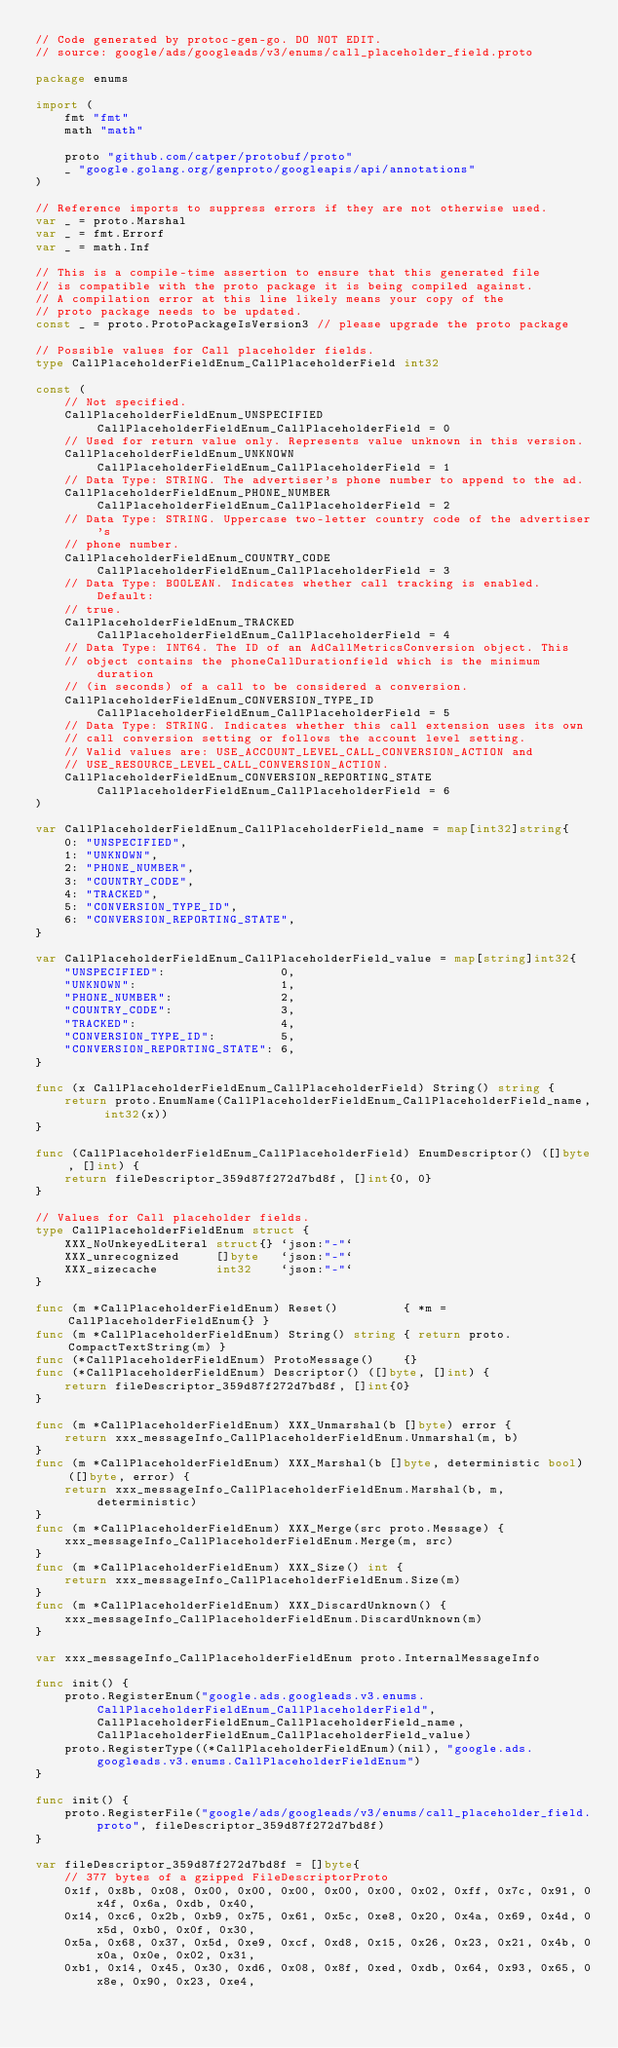<code> <loc_0><loc_0><loc_500><loc_500><_Go_>// Code generated by protoc-gen-go. DO NOT EDIT.
// source: google/ads/googleads/v3/enums/call_placeholder_field.proto

package enums

import (
	fmt "fmt"
	math "math"

	proto "github.com/catper/protobuf/proto"
	_ "google.golang.org/genproto/googleapis/api/annotations"
)

// Reference imports to suppress errors if they are not otherwise used.
var _ = proto.Marshal
var _ = fmt.Errorf
var _ = math.Inf

// This is a compile-time assertion to ensure that this generated file
// is compatible with the proto package it is being compiled against.
// A compilation error at this line likely means your copy of the
// proto package needs to be updated.
const _ = proto.ProtoPackageIsVersion3 // please upgrade the proto package

// Possible values for Call placeholder fields.
type CallPlaceholderFieldEnum_CallPlaceholderField int32

const (
	// Not specified.
	CallPlaceholderFieldEnum_UNSPECIFIED CallPlaceholderFieldEnum_CallPlaceholderField = 0
	// Used for return value only. Represents value unknown in this version.
	CallPlaceholderFieldEnum_UNKNOWN CallPlaceholderFieldEnum_CallPlaceholderField = 1
	// Data Type: STRING. The advertiser's phone number to append to the ad.
	CallPlaceholderFieldEnum_PHONE_NUMBER CallPlaceholderFieldEnum_CallPlaceholderField = 2
	// Data Type: STRING. Uppercase two-letter country code of the advertiser's
	// phone number.
	CallPlaceholderFieldEnum_COUNTRY_CODE CallPlaceholderFieldEnum_CallPlaceholderField = 3
	// Data Type: BOOLEAN. Indicates whether call tracking is enabled. Default:
	// true.
	CallPlaceholderFieldEnum_TRACKED CallPlaceholderFieldEnum_CallPlaceholderField = 4
	// Data Type: INT64. The ID of an AdCallMetricsConversion object. This
	// object contains the phoneCallDurationfield which is the minimum duration
	// (in seconds) of a call to be considered a conversion.
	CallPlaceholderFieldEnum_CONVERSION_TYPE_ID CallPlaceholderFieldEnum_CallPlaceholderField = 5
	// Data Type: STRING. Indicates whether this call extension uses its own
	// call conversion setting or follows the account level setting.
	// Valid values are: USE_ACCOUNT_LEVEL_CALL_CONVERSION_ACTION and
	// USE_RESOURCE_LEVEL_CALL_CONVERSION_ACTION.
	CallPlaceholderFieldEnum_CONVERSION_REPORTING_STATE CallPlaceholderFieldEnum_CallPlaceholderField = 6
)

var CallPlaceholderFieldEnum_CallPlaceholderField_name = map[int32]string{
	0: "UNSPECIFIED",
	1: "UNKNOWN",
	2: "PHONE_NUMBER",
	3: "COUNTRY_CODE",
	4: "TRACKED",
	5: "CONVERSION_TYPE_ID",
	6: "CONVERSION_REPORTING_STATE",
}

var CallPlaceholderFieldEnum_CallPlaceholderField_value = map[string]int32{
	"UNSPECIFIED":                0,
	"UNKNOWN":                    1,
	"PHONE_NUMBER":               2,
	"COUNTRY_CODE":               3,
	"TRACKED":                    4,
	"CONVERSION_TYPE_ID":         5,
	"CONVERSION_REPORTING_STATE": 6,
}

func (x CallPlaceholderFieldEnum_CallPlaceholderField) String() string {
	return proto.EnumName(CallPlaceholderFieldEnum_CallPlaceholderField_name, int32(x))
}

func (CallPlaceholderFieldEnum_CallPlaceholderField) EnumDescriptor() ([]byte, []int) {
	return fileDescriptor_359d87f272d7bd8f, []int{0, 0}
}

// Values for Call placeholder fields.
type CallPlaceholderFieldEnum struct {
	XXX_NoUnkeyedLiteral struct{} `json:"-"`
	XXX_unrecognized     []byte   `json:"-"`
	XXX_sizecache        int32    `json:"-"`
}

func (m *CallPlaceholderFieldEnum) Reset()         { *m = CallPlaceholderFieldEnum{} }
func (m *CallPlaceholderFieldEnum) String() string { return proto.CompactTextString(m) }
func (*CallPlaceholderFieldEnum) ProtoMessage()    {}
func (*CallPlaceholderFieldEnum) Descriptor() ([]byte, []int) {
	return fileDescriptor_359d87f272d7bd8f, []int{0}
}

func (m *CallPlaceholderFieldEnum) XXX_Unmarshal(b []byte) error {
	return xxx_messageInfo_CallPlaceholderFieldEnum.Unmarshal(m, b)
}
func (m *CallPlaceholderFieldEnum) XXX_Marshal(b []byte, deterministic bool) ([]byte, error) {
	return xxx_messageInfo_CallPlaceholderFieldEnum.Marshal(b, m, deterministic)
}
func (m *CallPlaceholderFieldEnum) XXX_Merge(src proto.Message) {
	xxx_messageInfo_CallPlaceholderFieldEnum.Merge(m, src)
}
func (m *CallPlaceholderFieldEnum) XXX_Size() int {
	return xxx_messageInfo_CallPlaceholderFieldEnum.Size(m)
}
func (m *CallPlaceholderFieldEnum) XXX_DiscardUnknown() {
	xxx_messageInfo_CallPlaceholderFieldEnum.DiscardUnknown(m)
}

var xxx_messageInfo_CallPlaceholderFieldEnum proto.InternalMessageInfo

func init() {
	proto.RegisterEnum("google.ads.googleads.v3.enums.CallPlaceholderFieldEnum_CallPlaceholderField", CallPlaceholderFieldEnum_CallPlaceholderField_name, CallPlaceholderFieldEnum_CallPlaceholderField_value)
	proto.RegisterType((*CallPlaceholderFieldEnum)(nil), "google.ads.googleads.v3.enums.CallPlaceholderFieldEnum")
}

func init() {
	proto.RegisterFile("google/ads/googleads/v3/enums/call_placeholder_field.proto", fileDescriptor_359d87f272d7bd8f)
}

var fileDescriptor_359d87f272d7bd8f = []byte{
	// 377 bytes of a gzipped FileDescriptorProto
	0x1f, 0x8b, 0x08, 0x00, 0x00, 0x00, 0x00, 0x00, 0x02, 0xff, 0x7c, 0x91, 0x4f, 0x6a, 0xdb, 0x40,
	0x14, 0xc6, 0x2b, 0xb9, 0x75, 0x61, 0x5c, 0xe8, 0x20, 0x4a, 0x69, 0x4d, 0x5d, 0xb0, 0x0f, 0x30,
	0x5a, 0x68, 0x37, 0x5d, 0xe9, 0xcf, 0xd8, 0x15, 0x26, 0x23, 0x21, 0x4b, 0x0a, 0x0e, 0x02, 0x31,
	0xb1, 0x14, 0x45, 0x30, 0xd6, 0x08, 0x8f, 0xed, 0xdb, 0x64, 0x93, 0x65, 0x8e, 0x90, 0x23, 0xe4,</code> 